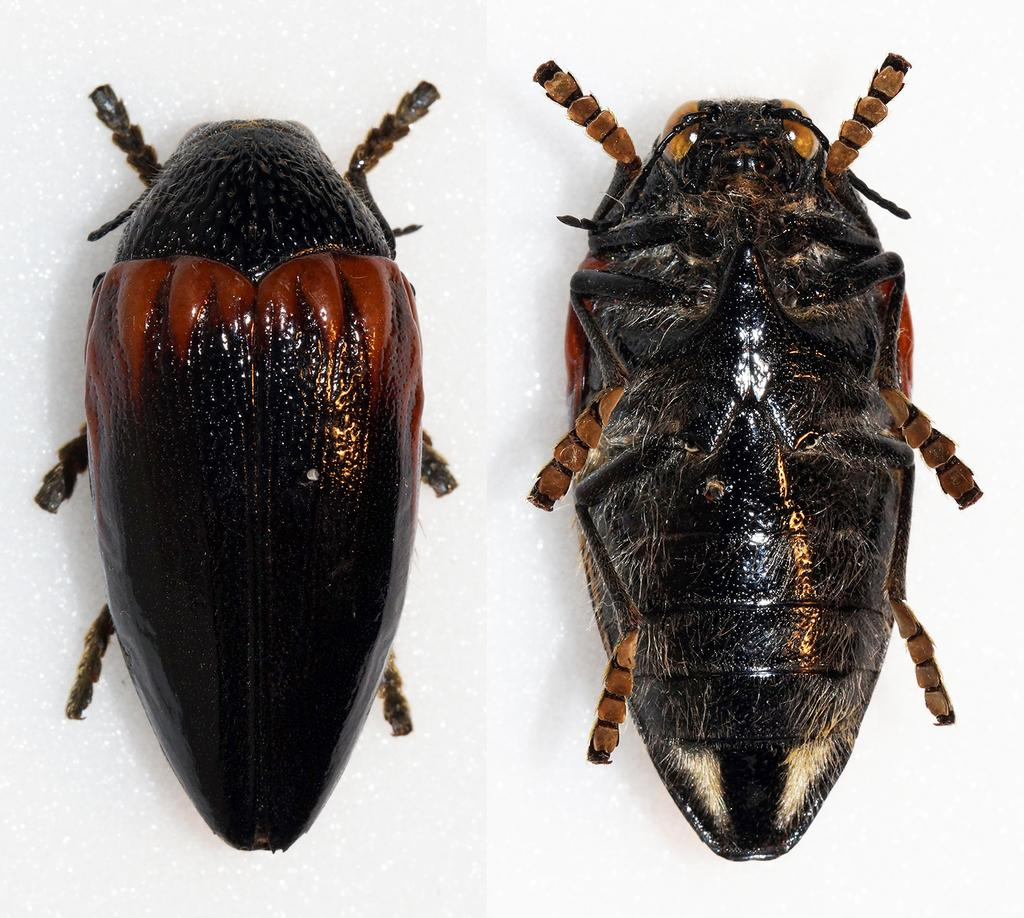How many insects can be seen in the image? There are two insects in the image. What is the background or surface on which the insects are located? The insects are on a white surface. What type of invention is being used by the deer in the image? There are no deer or inventions present in the image; it features two insects on a white surface. 